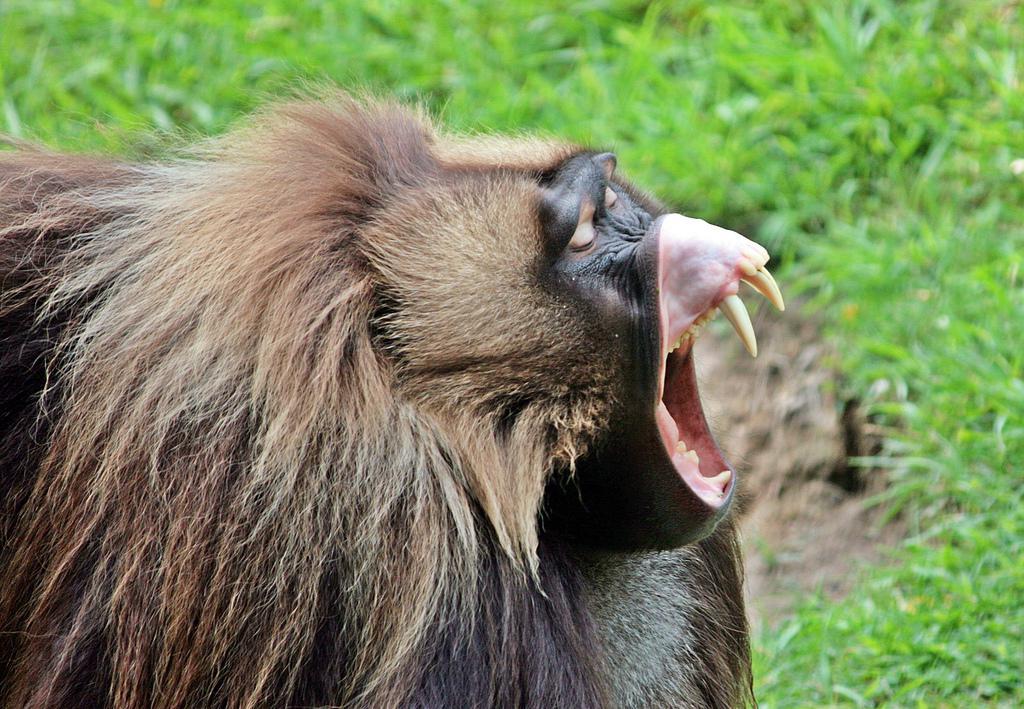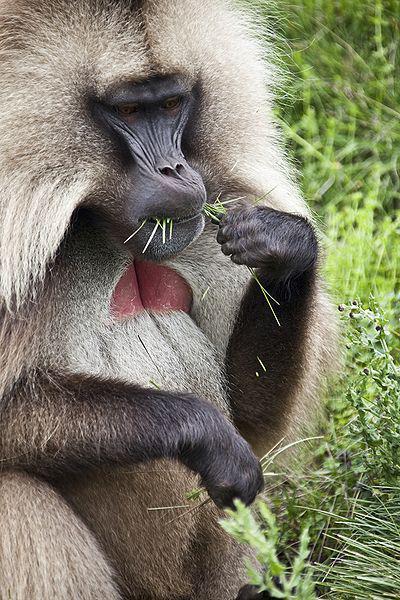The first image is the image on the left, the second image is the image on the right. Examine the images to the left and right. Is the description "An adult baboon is touching a dark-haired young baboon in one image." accurate? Answer yes or no. No. The first image is the image on the left, the second image is the image on the right. Evaluate the accuracy of this statement regarding the images: "A deceased animal is on the grass in front of a primate.". Is it true? Answer yes or no. No. 